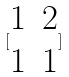Convert formula to latex. <formula><loc_0><loc_0><loc_500><loc_500>[ \begin{matrix} 1 & 2 \\ 1 & 1 \end{matrix} ]</formula> 